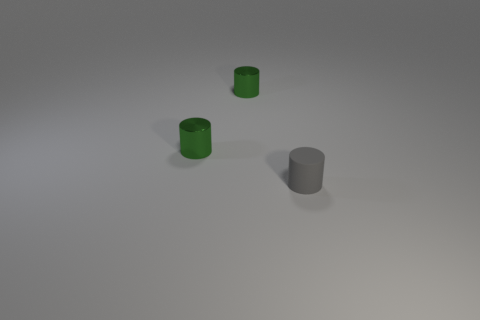Are there any other things that have the same material as the gray cylinder?
Offer a very short reply. No. How many yellow things are tiny objects or matte things?
Provide a succinct answer. 0. How many other things are the same shape as the matte object?
Make the answer very short. 2. There is a gray rubber object; are there any tiny metal cylinders right of it?
Ensure brevity in your answer.  No. How many green cylinders are the same material as the gray cylinder?
Your response must be concise. 0. What number of small objects are there?
Provide a succinct answer. 3. What number of metallic things are green cylinders or tiny blue objects?
Ensure brevity in your answer.  2. How many other things are there of the same color as the tiny rubber cylinder?
Your answer should be very brief. 0. What number of other things are there of the same material as the gray cylinder
Provide a short and direct response. 0. There is a tiny gray object; how many gray cylinders are on the right side of it?
Offer a terse response. 0. 